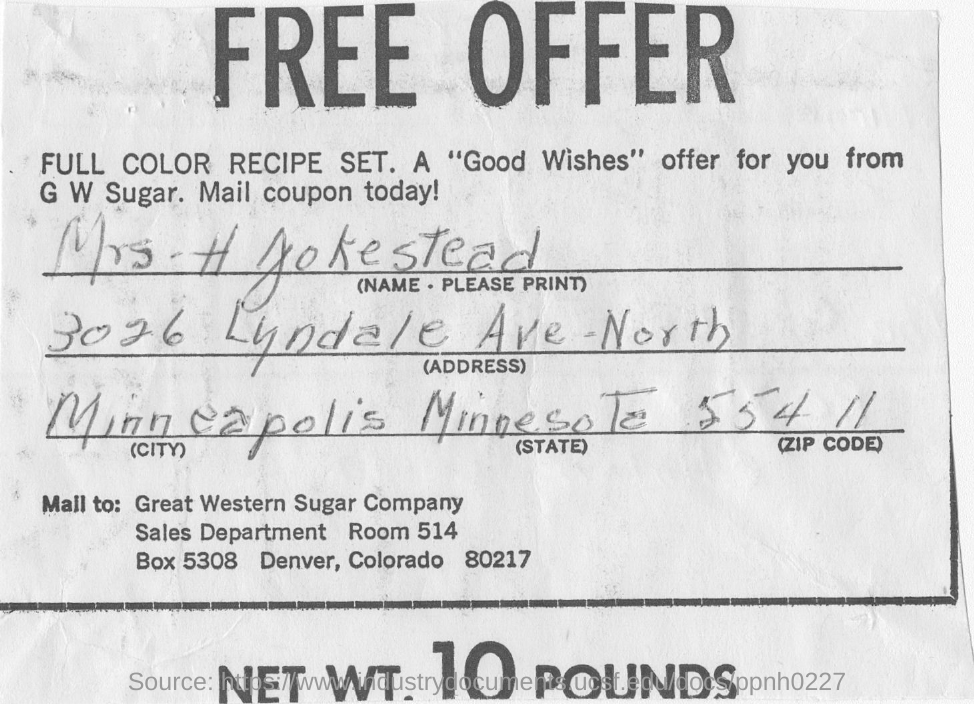Highlight a few significant elements in this photo. The sales department of the Great Western Sugar Company can be found in room 514. The person who filled the form resides in Minneapolis. This document is being offered at no cost. 